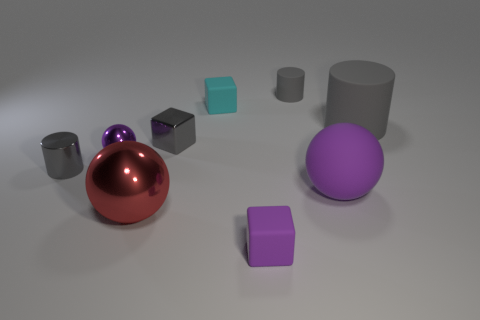Add 1 blue blocks. How many objects exist? 10 Subtract all spheres. How many objects are left? 6 Subtract 0 yellow spheres. How many objects are left? 9 Subtract all big purple rubber things. Subtract all big gray matte cubes. How many objects are left? 8 Add 5 purple matte objects. How many purple matte objects are left? 7 Add 2 large purple rubber spheres. How many large purple rubber spheres exist? 3 